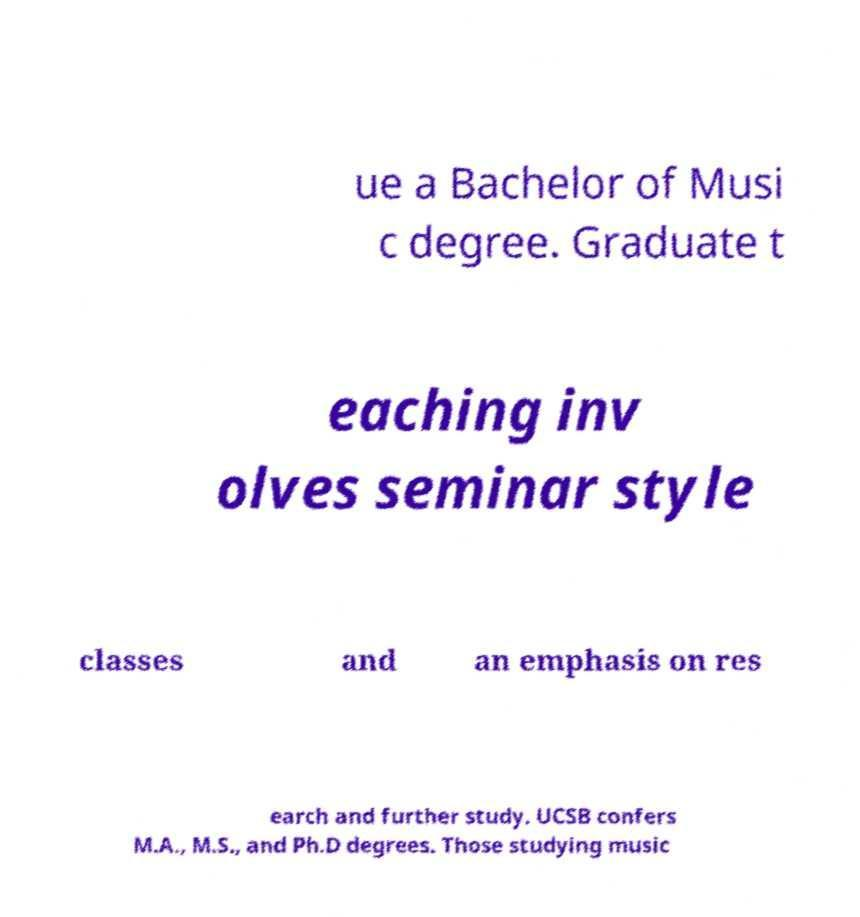Please identify and transcribe the text found in this image. ue a Bachelor of Musi c degree. Graduate t eaching inv olves seminar style classes and an emphasis on res earch and further study. UCSB confers M.A., M.S., and Ph.D degrees. Those studying music 